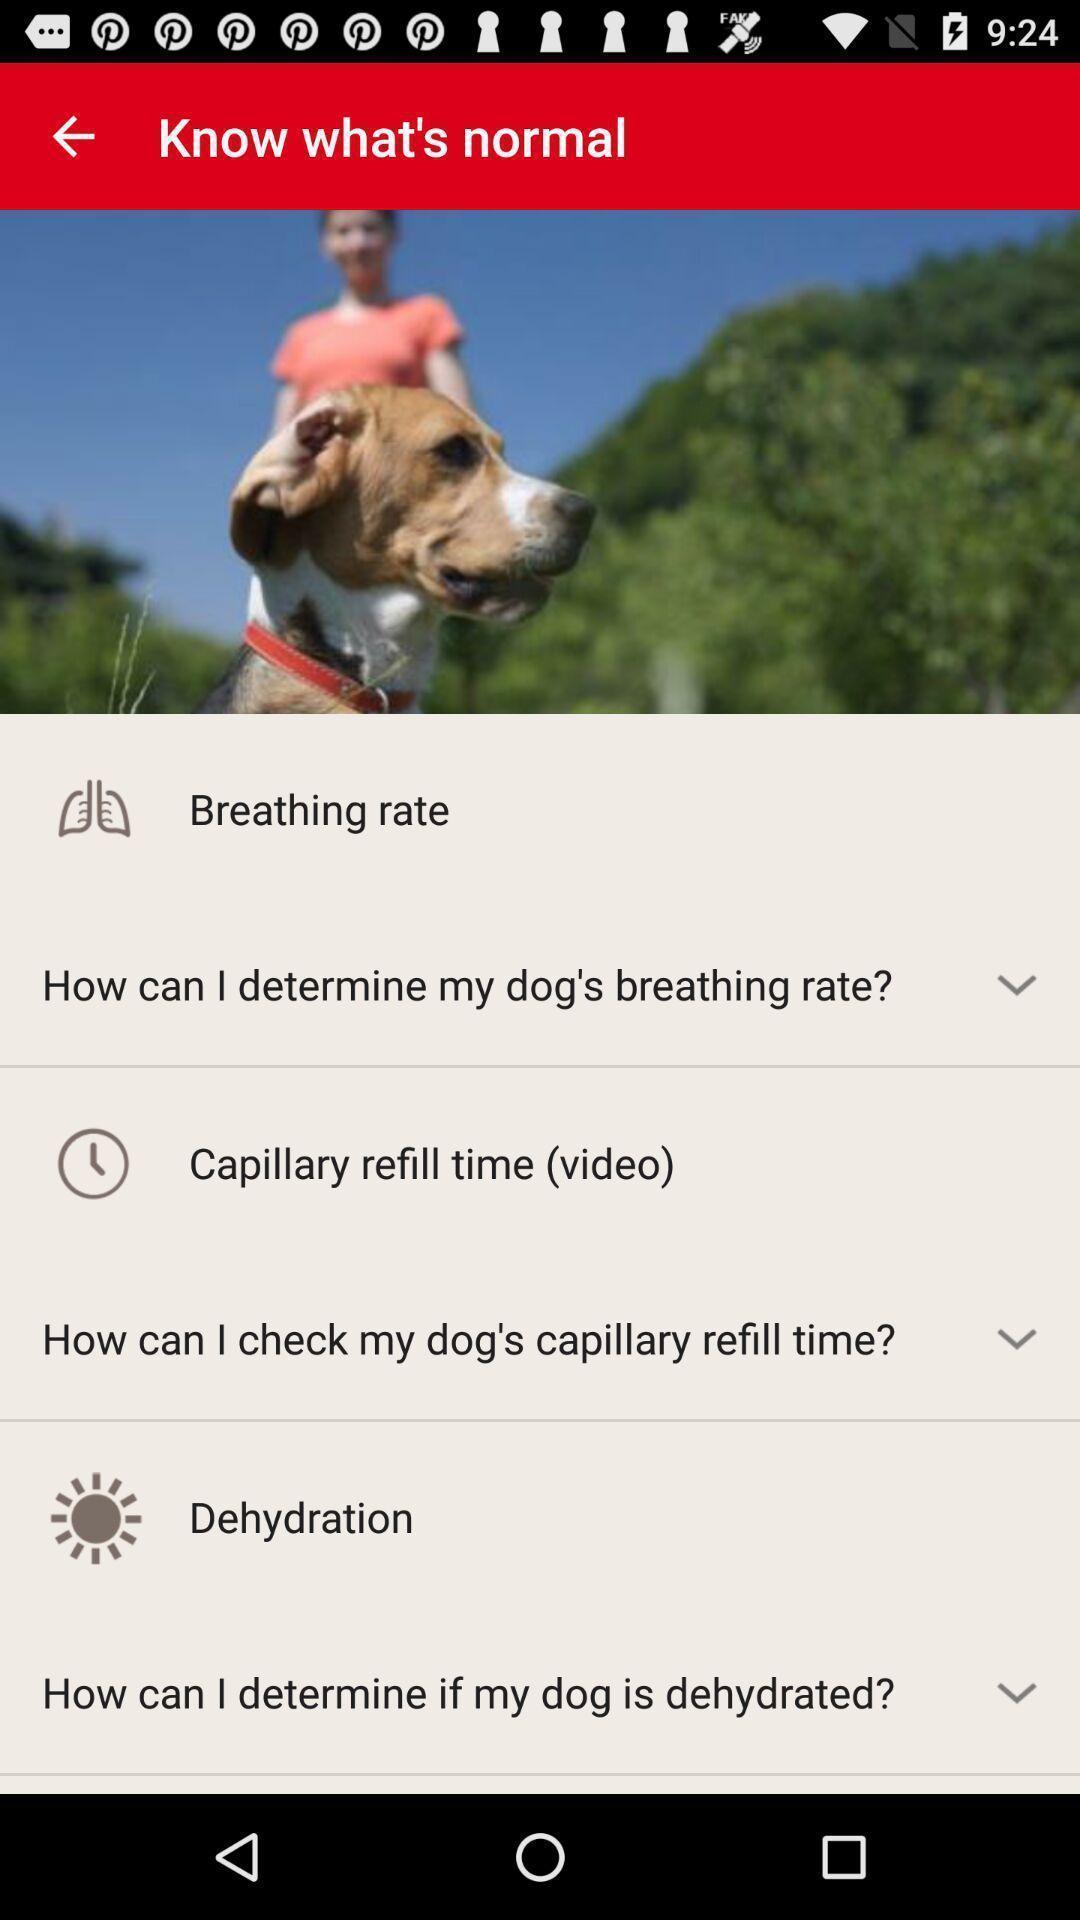What can you discern from this picture? Screen displaying dogs care app. 